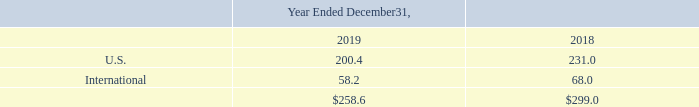18. Geographic Information
Property and equipment, net by geography was as follows:
No individual international country represented more than 10% of property and equipment, net in any period presented.
What information does the table show? Property and equipment, net by geography. What are the two geographic regions listed in the table? U.s., international. Which financial years' information is shown in the table? 2018, 2019. What is the average net property and equipment for 2018 and 2019 in U.S? (200.4+231.0)/2
Answer: 215.7. What is the average net property and equipment for 2018 and 2019 Internationally? (58.2+68.0)/2
Answer: 63.1. Between 2018 and 2019, which year has higher net property and equipment in U.S.? 231.0>200.4
Answer: 2018. 